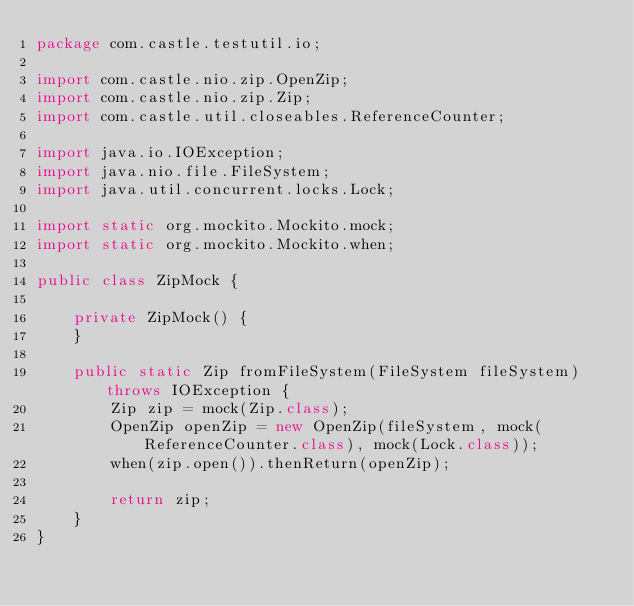Convert code to text. <code><loc_0><loc_0><loc_500><loc_500><_Java_>package com.castle.testutil.io;

import com.castle.nio.zip.OpenZip;
import com.castle.nio.zip.Zip;
import com.castle.util.closeables.ReferenceCounter;

import java.io.IOException;
import java.nio.file.FileSystem;
import java.util.concurrent.locks.Lock;

import static org.mockito.Mockito.mock;
import static org.mockito.Mockito.when;

public class ZipMock {

    private ZipMock() {
    }

    public static Zip fromFileSystem(FileSystem fileSystem) throws IOException {
        Zip zip = mock(Zip.class);
        OpenZip openZip = new OpenZip(fileSystem, mock(ReferenceCounter.class), mock(Lock.class));
        when(zip.open()).thenReturn(openZip);

        return zip;
    }
}
</code> 